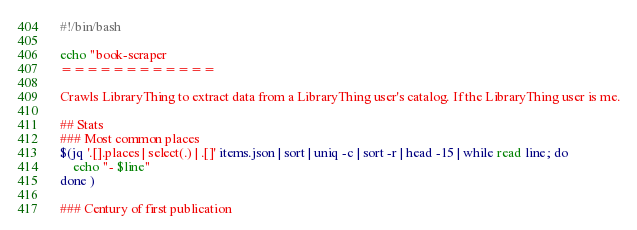<code> <loc_0><loc_0><loc_500><loc_500><_Bash_>#!/bin/bash

echo "book-scraper
============

Crawls LibraryThing to extract data from a LibraryThing user's catalog. If the LibraryThing user is me.

## Stats
### Most common places
$(jq '.[].places | select(.) | .[]' items.json | sort | uniq -c | sort -r | head -15 | while read line; do
    echo "- $line"
done )

### Century of first publication</code> 